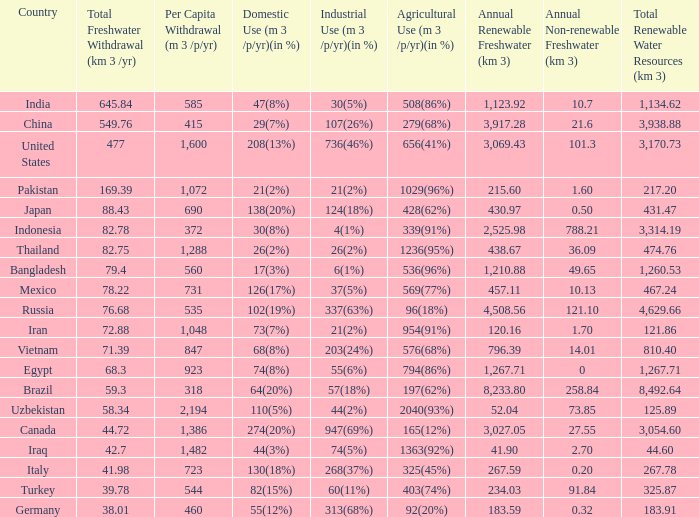What is Industrial Use (m 3 /p/yr)(in %), when Total Freshwater Withdrawal (km 3/yr) is less than 82.75, and when Agricultural Use (m 3 /p/yr)(in %) is 1363(92%)? 74(5%). 